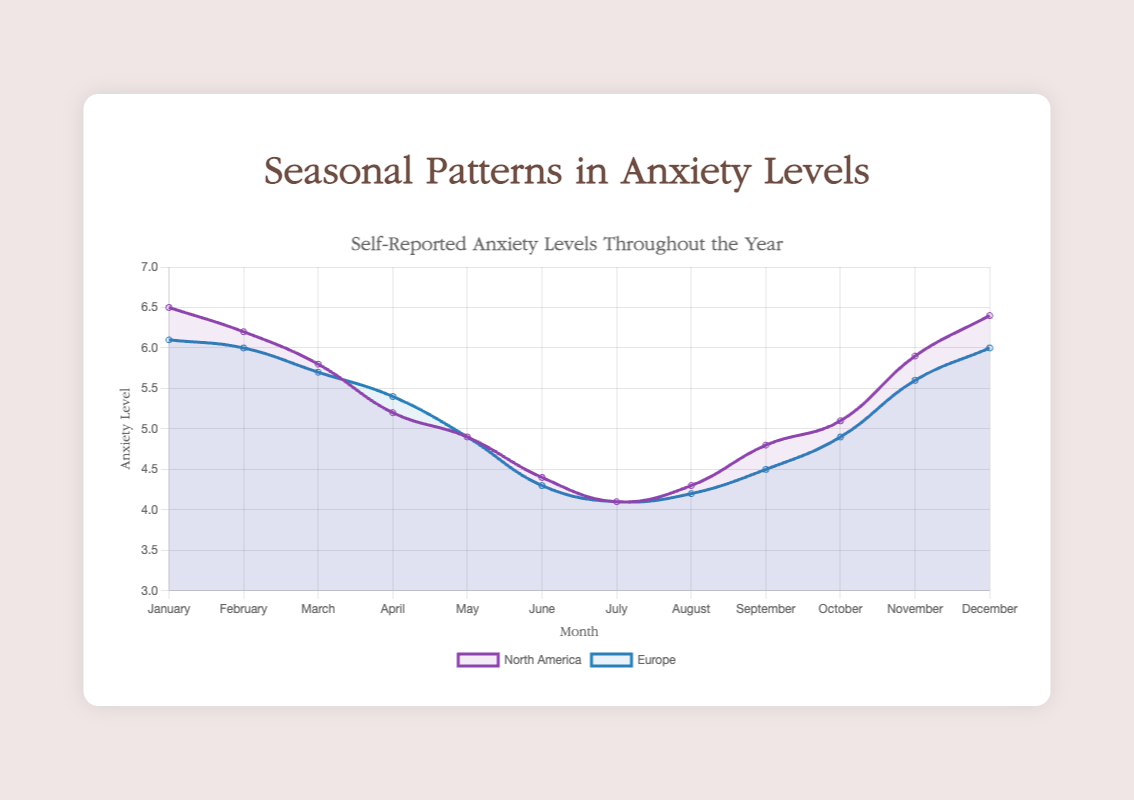what trend do you see in anxiety levels over the year for North America? The anxiety levels in North America start at a high in January, decrease through the summer months, hitting their lowest point in July, and then begin to increase again towards December. This suggests a U-shaped trend with mid-year being the least anxious period.
Answer: A U-shaped trend Which month has the highest self-reported anxiety level in Europe? By observing the curve for Europe, the highest point on the graph is in January. Thus, January has the highest self-reported anxiety level for Europe.
Answer: January Compare the anxiety levels in June between North America and Europe. Which region has a higher level, and by how much? In June, North America has an anxiety level of 4.4, and Europe has an anxiety level of 4.3. Comparing the two, North America has a slightly higher anxiety level by 0.1 units.
Answer: North America, by 0.1 What is the average anxiety level across the months of August, September, and October in North America? The anxiety levels for August, September, and October in North America are 4.3, 4.8, and 5.1, respectively. Adding them up gives 14.2, and the average is 14.2 / 3 = 4.73.
Answer: 4.73 What visual difference in colors can you observe between the anxiety levels of North America and Europe? The anxiety levels for North America are represented by curves and area shading in purple color, while Europe's anxiety levels are represented by blue curves and shading. This helps visually distinguish between the two regions.
Answer: Purple for North America, Blue for Europe Which month shows the largest drop in anxiety levels from the previous month for North America? To find the largest drop, calculate the differences between consecutive months. The largest drop is from January to February: 6.5 - 6.2 = 0.3. The calculation reveals that the drop from January to February (6.5 to 6.2) is the largest.
Answer: January to February During which months do North America and Europe have approximately equal anxiety levels? By examining the curves for approximate equal levels, around May both regions have similar levels with North America at 4.9 and Europe also at 4.9, hence they are approximately equal during this month.
Answer: May How does the anxiety level in December compare between North America and Europe? In December, the anxiety level for North America is 6.4, while for Europe it is 6.0. Thus, North America's anxiety level is higher by 0.4 units compared to Europe.
Answer: North America, by 0.4 